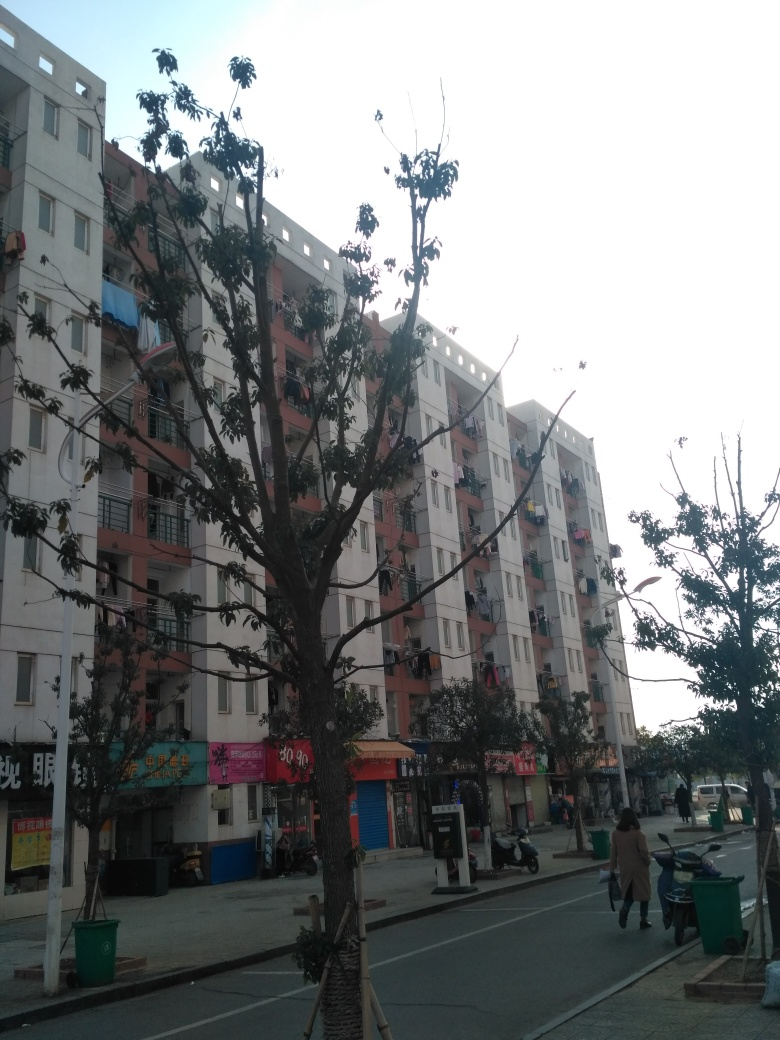How is the composition of the image?
A. Messy
B. Average
C. Quite suitable The composition of the image strikes a balance between organization and everyday life activity. The elements are arranged in a way that guides the viewer's eye along the street and the building, thus making the composition quite suitable (C). It presents a realistic urban scene without clutter that might be categorized as messy, but at the same time, it doesn't have a polished, deliberate arrangement one might find in a more artfully taken photograph. 